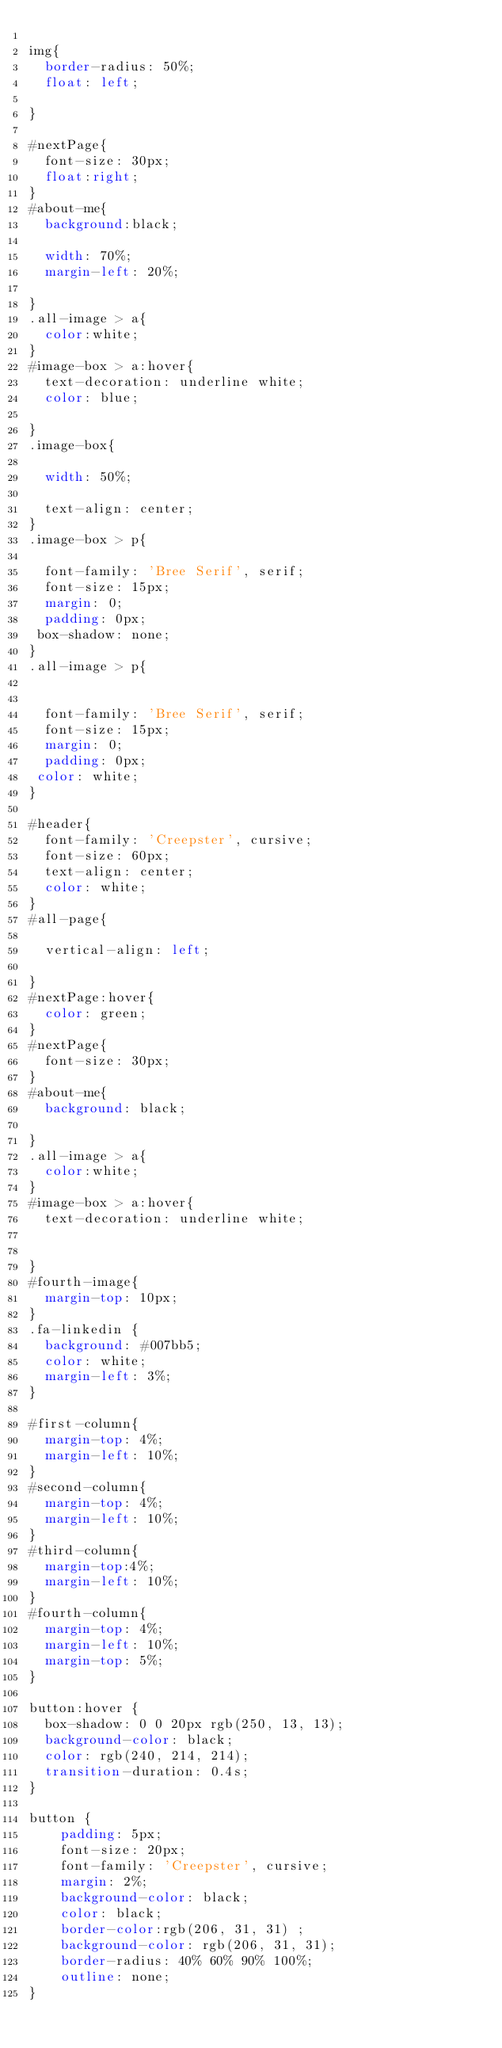Convert code to text. <code><loc_0><loc_0><loc_500><loc_500><_CSS_>
img{
  border-radius: 50%;
  float: left;
  
}

#nextPage{
  font-size: 30px;
  float:right;
}
#about-me{
  background:black;
 
  width: 70%;
  margin-left: 20%;
  
}
.all-image > a{
  color:white;
}
#image-box > a:hover{
  text-decoration: underline white;
  color: blue;
  
}
.image-box{

  width: 50%;

  text-align: center;
}
.image-box > p{
  
  font-family: 'Bree Serif', serif;
  font-size: 15px;
  margin: 0;
  padding: 0px;
 box-shadow: none;
}
.all-image > p{


  font-family: 'Bree Serif', serif;
  font-size: 15px;
  margin: 0;
  padding: 0px;
 color: white;
}

#header{
  font-family: 'Creepster', cursive;
  font-size: 60px;
  text-align: center;
  color: white;
}
#all-page{
 
  vertical-align: left;
 
}
#nextPage:hover{
  color: green;
}
#nextPage{
  font-size: 30px;
}
#about-me{
  background: black;
 
}
.all-image > a{
  color:white;
}
#image-box > a:hover{
  text-decoration: underline white;

  
}
#fourth-image{
  margin-top: 10px;
}
.fa-linkedin {
  background: #007bb5;
  color: white;
  margin-left: 3%;
}

#first-column{
  margin-top: 4%;
  margin-left: 10%;
}
#second-column{
  margin-top: 4%;
  margin-left: 10%;
}
#third-column{
  margin-top:4%;
  margin-left: 10%;
}
#fourth-column{
  margin-top: 4%;
  margin-left: 10%;
  margin-top: 5%;
}

button:hover {
  box-shadow: 0 0 20px rgb(250, 13, 13);
  background-color: black;
  color: rgb(240, 214, 214);
  transition-duration: 0.4s;
}

button {
    padding: 5px;
    font-size: 20px;
    font-family: 'Creepster', cursive;
    margin: 2%;
    background-color: black;
    color: black;
    border-color:rgb(206, 31, 31) ;
    background-color: rgb(206, 31, 31);
    border-radius: 40% 60% 90% 100%;
    outline: none;
}

</code> 